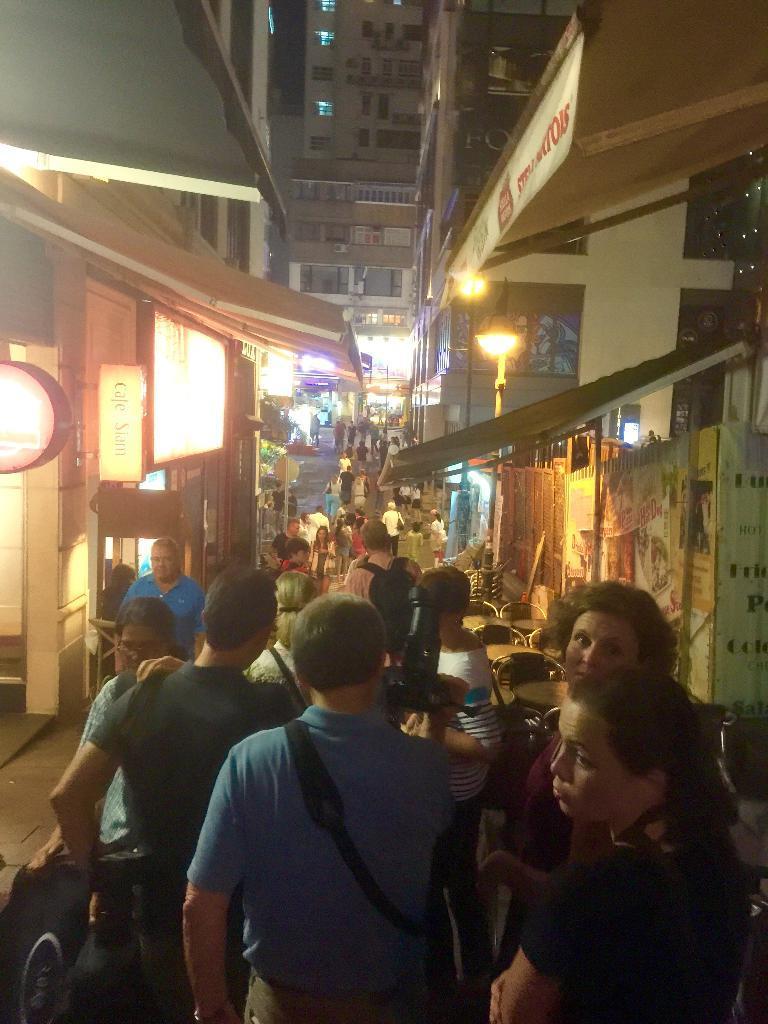How would you summarize this image in a sentence or two? In this picture i can see many peoples were standing beside the shops. In the background i can see the buildings. On the right i can see the street light, posters, gate and fencing. In the bottom left corner there is a woman who is wearing black dress. She is standing near to the woman who is wearing a bag. 